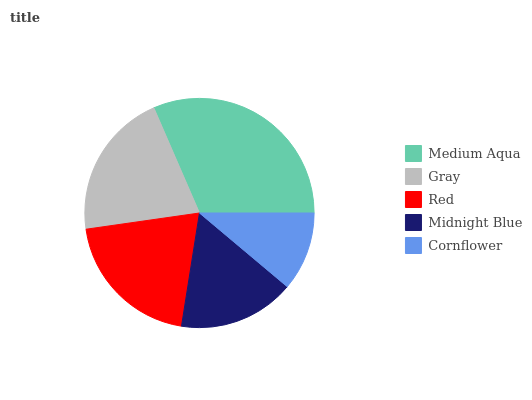Is Cornflower the minimum?
Answer yes or no. Yes. Is Medium Aqua the maximum?
Answer yes or no. Yes. Is Gray the minimum?
Answer yes or no. No. Is Gray the maximum?
Answer yes or no. No. Is Medium Aqua greater than Gray?
Answer yes or no. Yes. Is Gray less than Medium Aqua?
Answer yes or no. Yes. Is Gray greater than Medium Aqua?
Answer yes or no. No. Is Medium Aqua less than Gray?
Answer yes or no. No. Is Red the high median?
Answer yes or no. Yes. Is Red the low median?
Answer yes or no. Yes. Is Midnight Blue the high median?
Answer yes or no. No. Is Gray the low median?
Answer yes or no. No. 